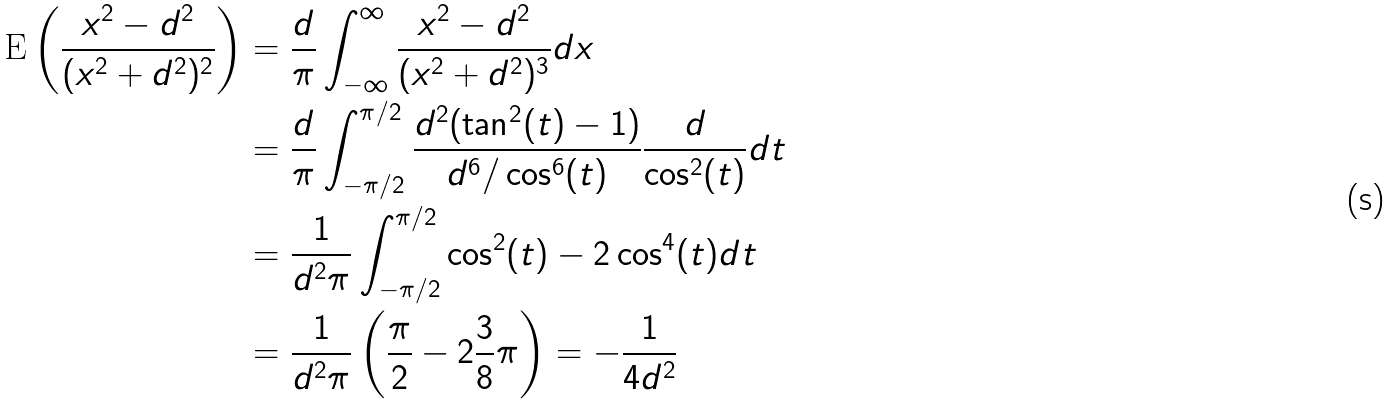<formula> <loc_0><loc_0><loc_500><loc_500>\text {E} \left ( \frac { x ^ { 2 } - d ^ { 2 } } { ( x ^ { 2 } + d ^ { 2 } ) ^ { 2 } } \right ) & = \frac { d } { \pi } \int _ { - \infty } ^ { \infty } \frac { x ^ { 2 } - d ^ { 2 } } { ( x ^ { 2 } + d ^ { 2 } ) ^ { 3 } } d x \\ & = \frac { d } { \pi } \int _ { - \pi / 2 } ^ { \pi / 2 } \frac { d ^ { 2 } ( \tan ^ { 2 } ( t ) - 1 ) } { d ^ { 6 } / \cos ^ { 6 } ( t ) } \frac { d } { \cos ^ { 2 } ( t ) } d t \\ & = \frac { 1 } { d ^ { 2 } \pi } \int _ { - \pi / 2 } ^ { \pi / 2 } \cos ^ { 2 } ( t ) - 2 \cos ^ { 4 } ( t ) d t \\ & = \frac { 1 } { d ^ { 2 } \pi } \left ( \frac { \pi } { 2 } - 2 \frac { 3 } { 8 } \pi \right ) = - \frac { 1 } { 4 d ^ { 2 } }</formula> 